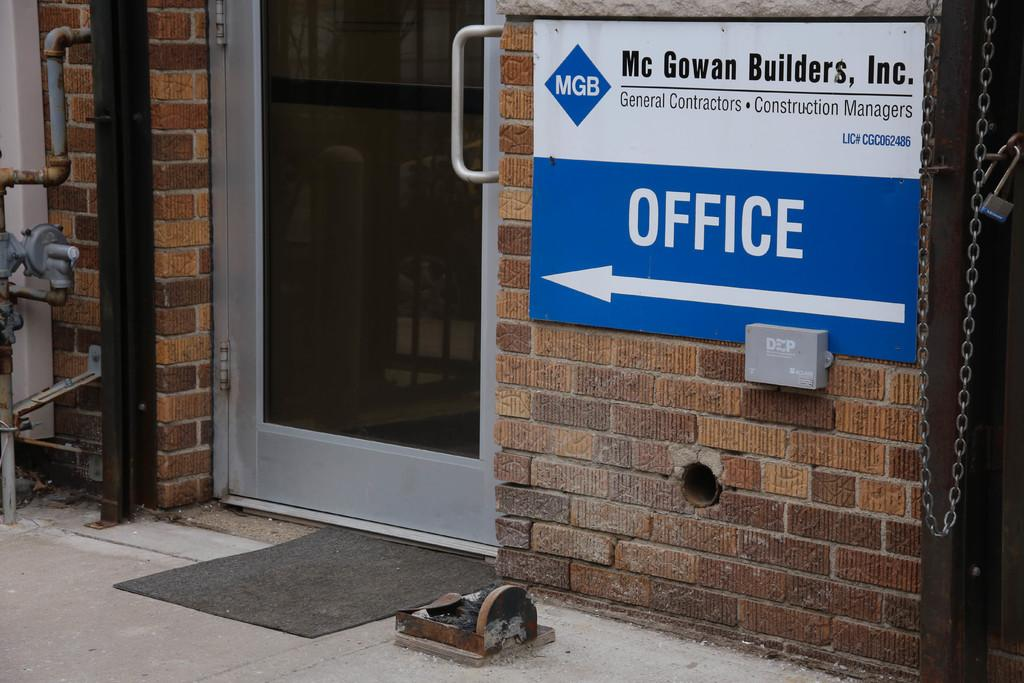What is the main object in the image? There is a door in the image. What feature does the door have? The door has a handle. What other objects can be seen in the image? There is a board, a wall, poles, pipes, a machine, a chain rod, a lock, and a mat in the image. What is visible at the bottom of the image? The floor is visible at the bottom of the image. What order are the objects arranged in the image? The provided facts do not give information about the arrangement or order of the objects in the image. --- Facts: 1. There is a person in the image. 2. The person is wearing a hat. 3. The person is holding a book. 4. There is a table in the image. 5. The table has a lamp on it. 6. There is a chair next to the table. 7. The chair has a cushion on it. 8. There is a window in the image. 9. The window has curtains on it. Absurd Topics: dance, ocean, parrot Conversation: Who is in the image? There is a person in the image. What is the person wearing? The person is wearing a hat. What is the person holding? The person is holding a book. What furniture is in the image? There is a table and a chair in the image. What is on the table? The table has a lamp on it. What is on the chair? The chair has a cushion on it. What is visible outside the window? The provided facts do not give information about what is visible outside the window. Reasoning: Let's think step by step in order to produce the conversation. We start by identifying the main subject in the image, which is the person. Then, we describe the person's clothing and what they are holding. Next, we list the furniture present in the image, including the table, lamp, chair, and cushion. Finally, we mention the window and its curtains, but we do not speculate about what is visible outside the window since the provided facts do not give that information. Absurd Question/Answer: Can you see the person dancing with a parrot in the image? No, there is no dancing person or parrot present in the image. 